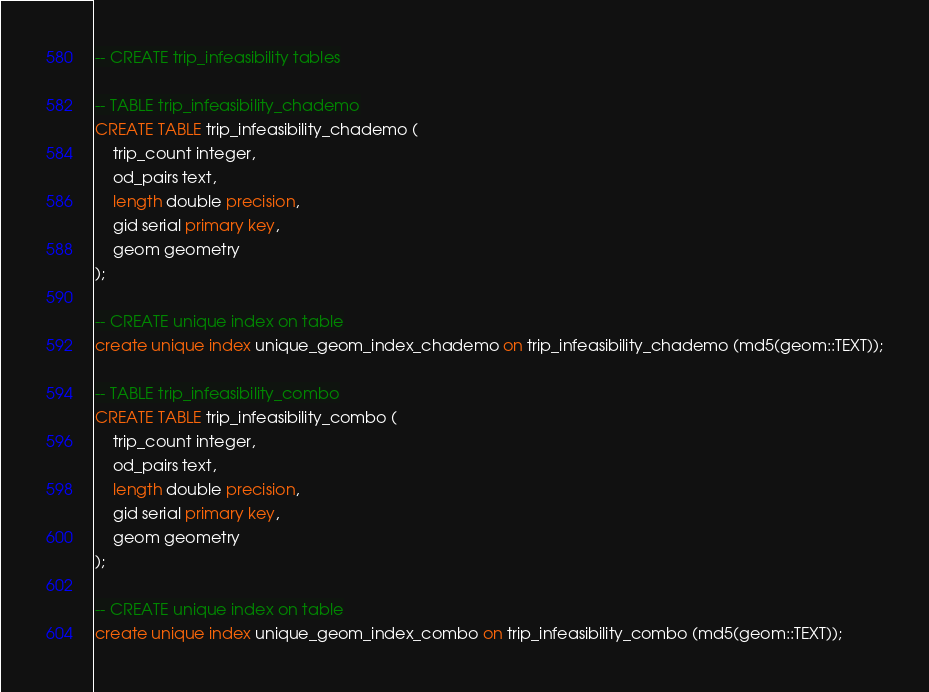Convert code to text. <code><loc_0><loc_0><loc_500><loc_500><_SQL_>-- CREATE trip_infeasibility tables

-- TABLE trip_infeasibility_chademo
CREATE TABLE trip_infeasibility_chademo (
    trip_count integer, 
    od_pairs text, 
    length double precision, 
    gid serial primary key, 
    geom geometry
);

-- CREATE unique index on table
create unique index unique_geom_index_chademo on trip_infeasibility_chademo (md5(geom::TEXT));

-- TABLE trip_infeasibility_combo
CREATE TABLE trip_infeasibility_combo (
    trip_count integer, 
    od_pairs text, 
    length double precision, 
    gid serial primary key, 
    geom geometry
);

-- CREATE unique index on table
create unique index unique_geom_index_combo on trip_infeasibility_combo (md5(geom::TEXT));</code> 